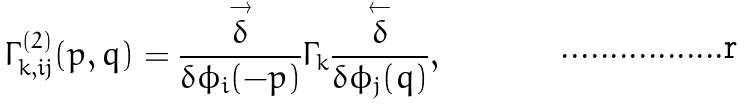Convert formula to latex. <formula><loc_0><loc_0><loc_500><loc_500>\Gamma _ { k , i j } ^ { ( 2 ) } ( p , q ) = \frac { \overset { \rightarrow } { \delta } } { \delta \phi _ { i } ( - p ) } \Gamma _ { k } \frac { \overset { \leftarrow } \delta } { \delta \phi _ { j } ( q ) } ,</formula> 